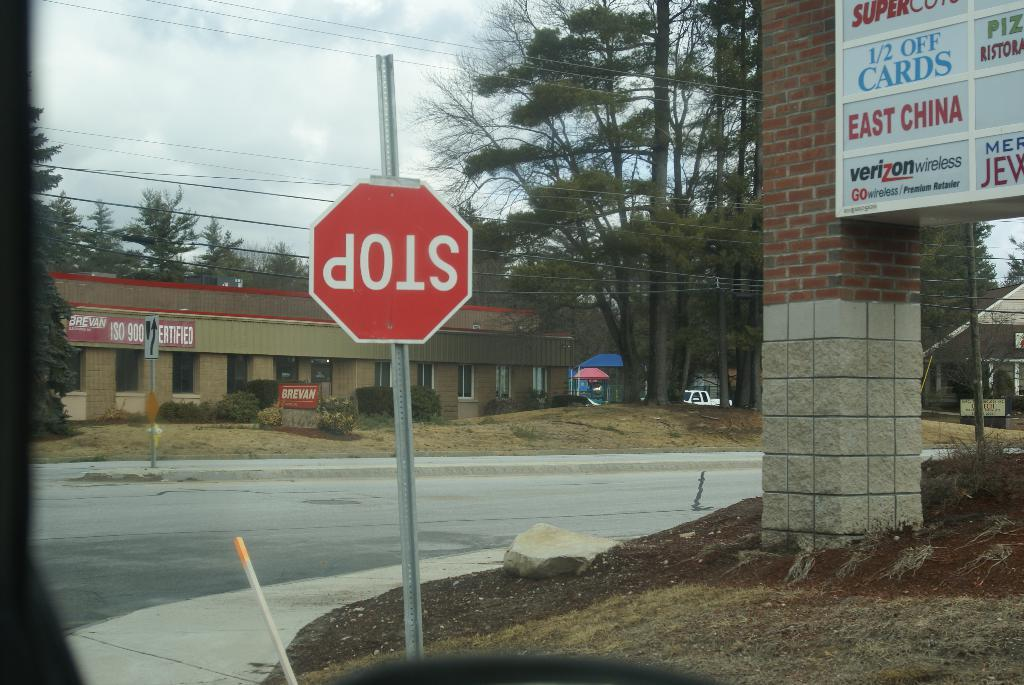<image>
Render a clear and concise summary of the photo. Stop sign is turned upside down outside on the sidewalk 